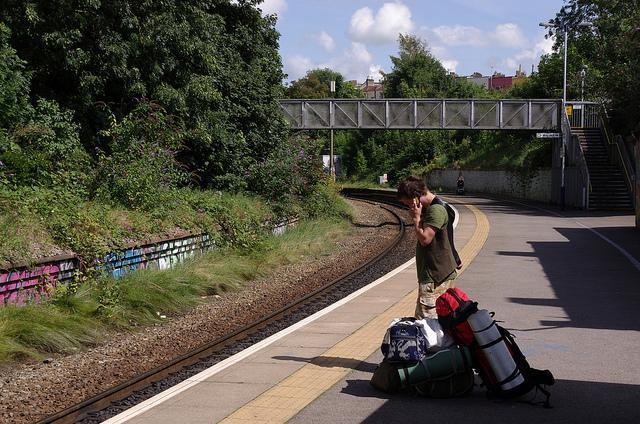How many backpacks can be seen?
Give a very brief answer. 2. How many giraffes are there?
Give a very brief answer. 0. 